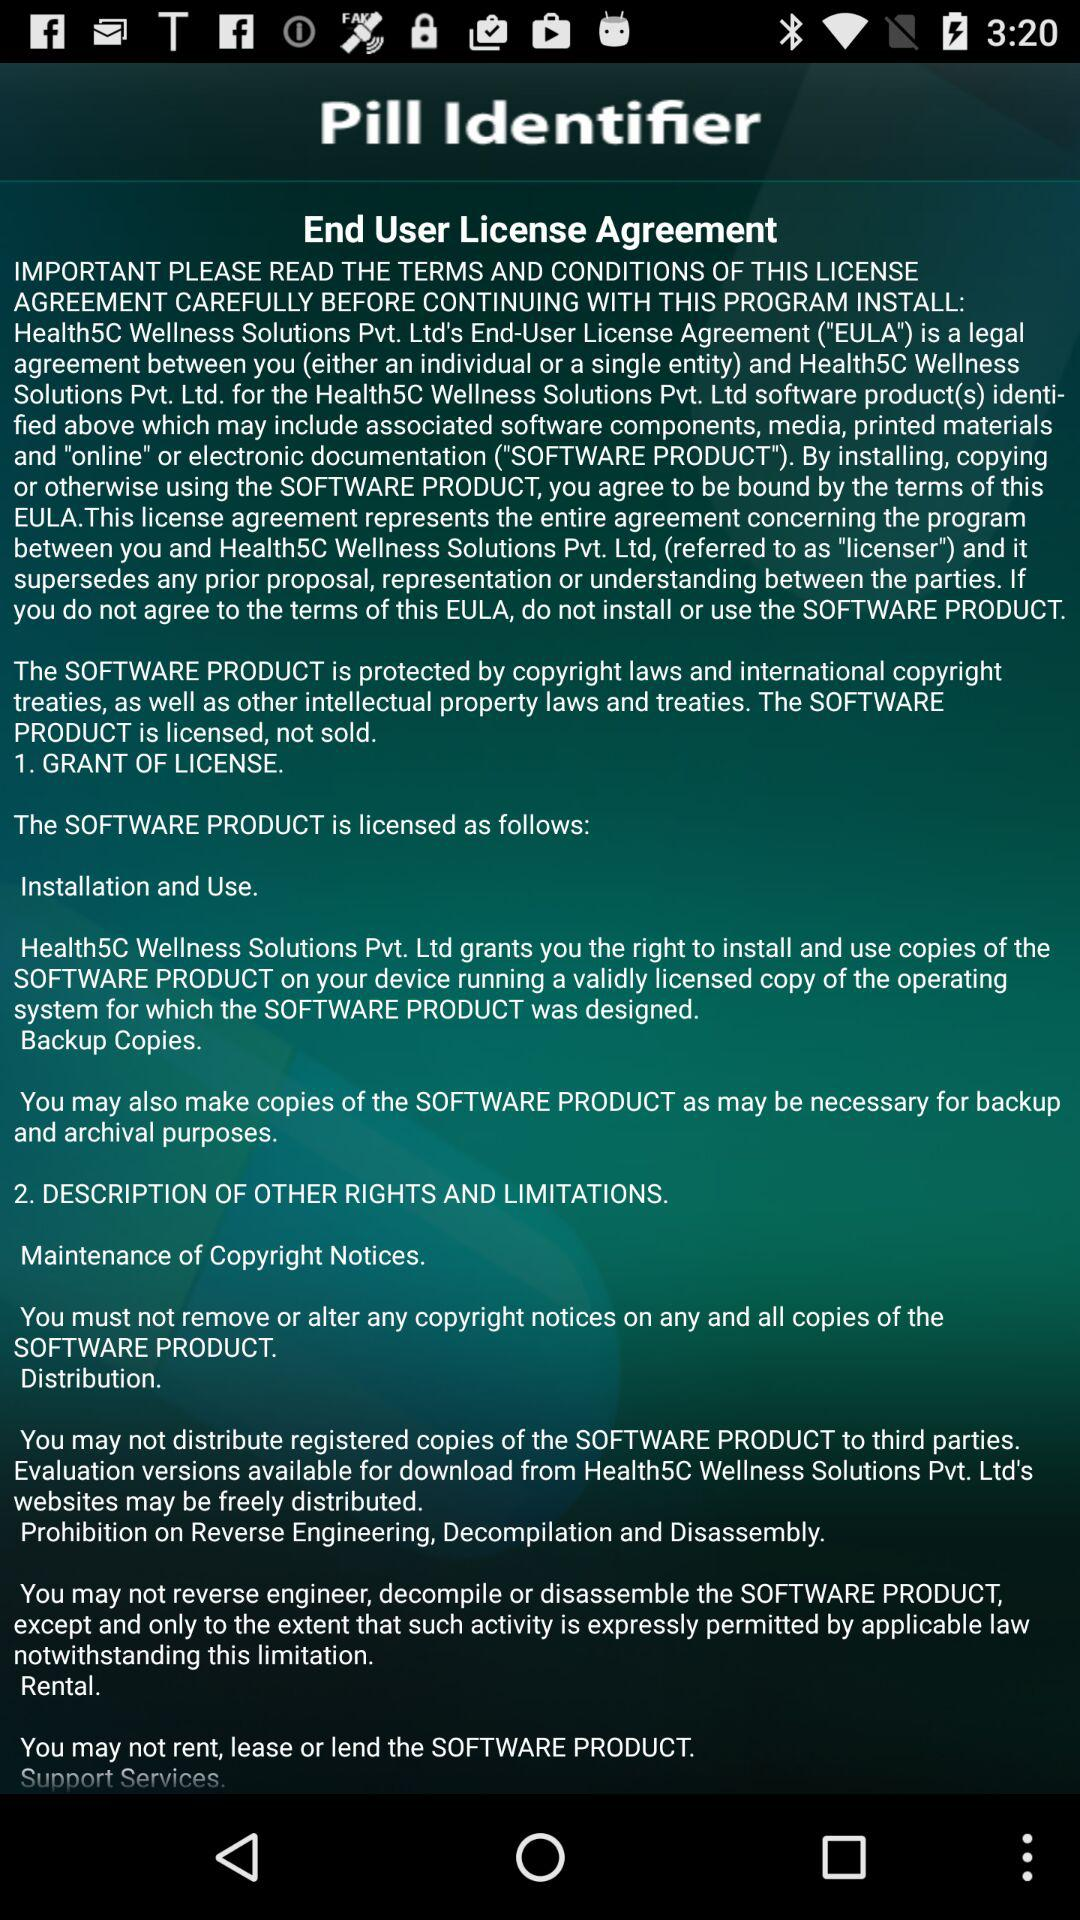Which pills have been identified?
When the provided information is insufficient, respond with <no answer>. <no answer> 